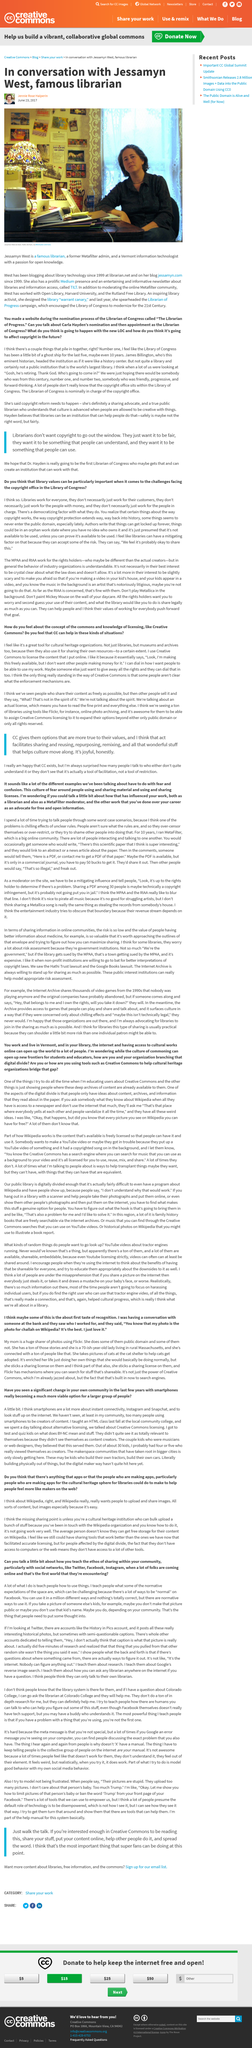Specify some key components in this picture. Jessamyn West designed the library "warrant canary. Yes, Jessamyn West is a well-known librarian who has been writing about library technology on her blog since 1999. The URL for West's blog is [jessamyn.com](http://jessamyn.com). 